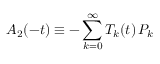Convert formula to latex. <formula><loc_0><loc_0><loc_500><loc_500>A _ { 2 } ( - t ) \equiv - \sum _ { k = 0 } ^ { \infty } T _ { k } ( t ) \, P _ { k }</formula> 